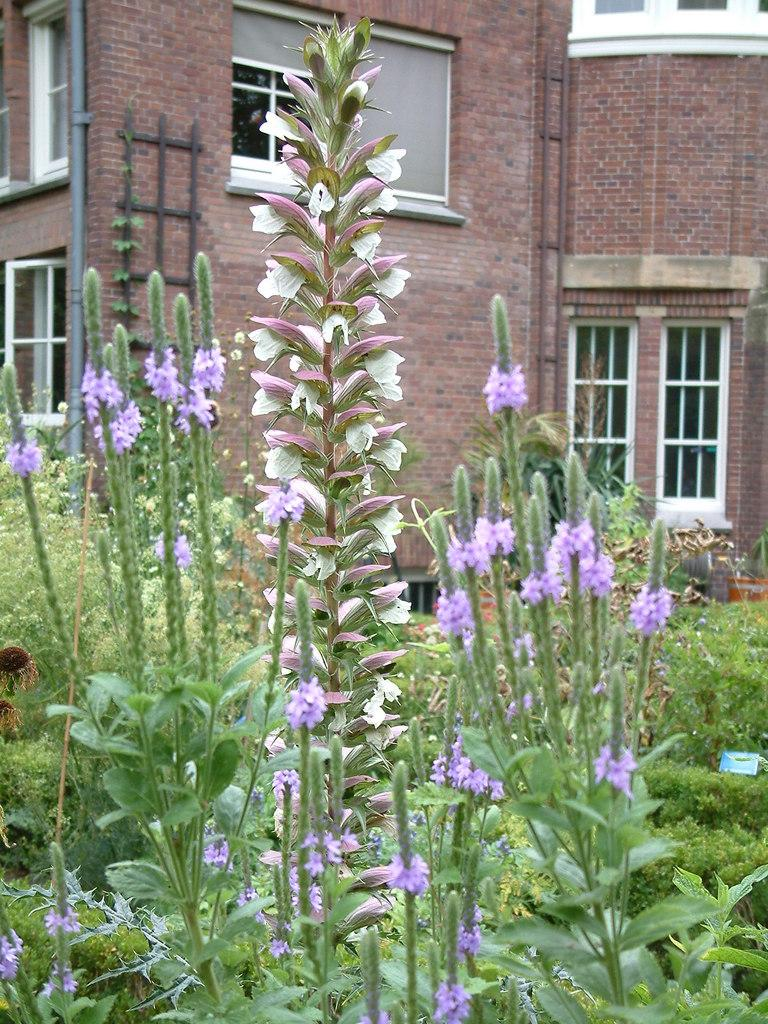What type of vegetation can be seen in the image? There are groups of trees in the image. What structure is visible in the background of the image? There is a building in the background of the image. What type of haircut does the fact have in the image? There is no fact or haircut present in the image; it features groups of trees and a building in the background. 